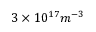Convert formula to latex. <formula><loc_0><loc_0><loc_500><loc_500>3 \times 1 0 ^ { 1 7 } m ^ { - 3 }</formula> 